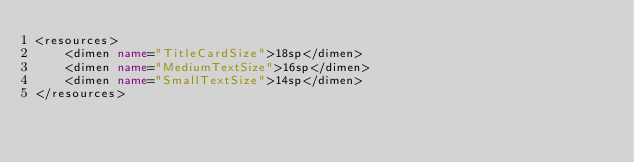Convert code to text. <code><loc_0><loc_0><loc_500><loc_500><_XML_><resources>
	<dimen name="TitleCardSize">18sp</dimen>
	<dimen name="MediumTextSize">16sp</dimen>
	<dimen name="SmallTextSize">14sp</dimen>
</resources></code> 